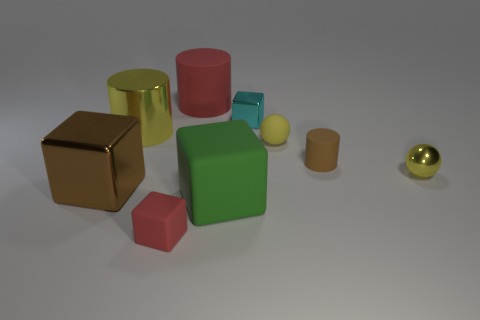Is there a thing of the same color as the rubber ball?
Offer a terse response. Yes. What number of red matte things are on the right side of the shiny object left of the big yellow metal cylinder?
Provide a succinct answer. 2. Are there more brown blocks than large brown matte blocks?
Ensure brevity in your answer.  Yes. Are the big green block and the tiny brown thing made of the same material?
Make the answer very short. Yes. Is the number of large shiny cylinders that are in front of the tiny red rubber thing the same as the number of big red cylinders?
Keep it short and to the point. No. How many large red objects have the same material as the tiny cyan block?
Your answer should be very brief. 0. Are there fewer big yellow metal objects than yellow metal things?
Your answer should be very brief. Yes. There is a big cylinder that is behind the tiny cyan block; does it have the same color as the tiny matte sphere?
Offer a very short reply. No. There is a red matte object in front of the big cylinder left of the big red matte object; what number of objects are behind it?
Your answer should be very brief. 8. There is a tiny yellow shiny sphere; what number of cyan cubes are in front of it?
Make the answer very short. 0. 